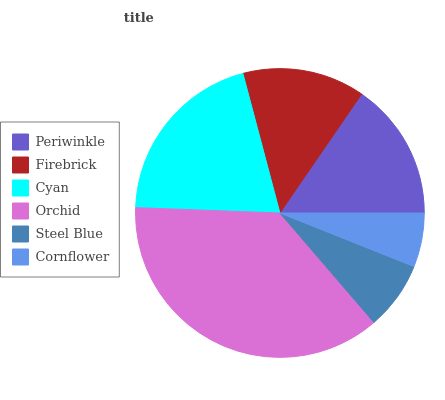Is Cornflower the minimum?
Answer yes or no. Yes. Is Orchid the maximum?
Answer yes or no. Yes. Is Firebrick the minimum?
Answer yes or no. No. Is Firebrick the maximum?
Answer yes or no. No. Is Periwinkle greater than Firebrick?
Answer yes or no. Yes. Is Firebrick less than Periwinkle?
Answer yes or no. Yes. Is Firebrick greater than Periwinkle?
Answer yes or no. No. Is Periwinkle less than Firebrick?
Answer yes or no. No. Is Periwinkle the high median?
Answer yes or no. Yes. Is Firebrick the low median?
Answer yes or no. Yes. Is Cyan the high median?
Answer yes or no. No. Is Cornflower the low median?
Answer yes or no. No. 